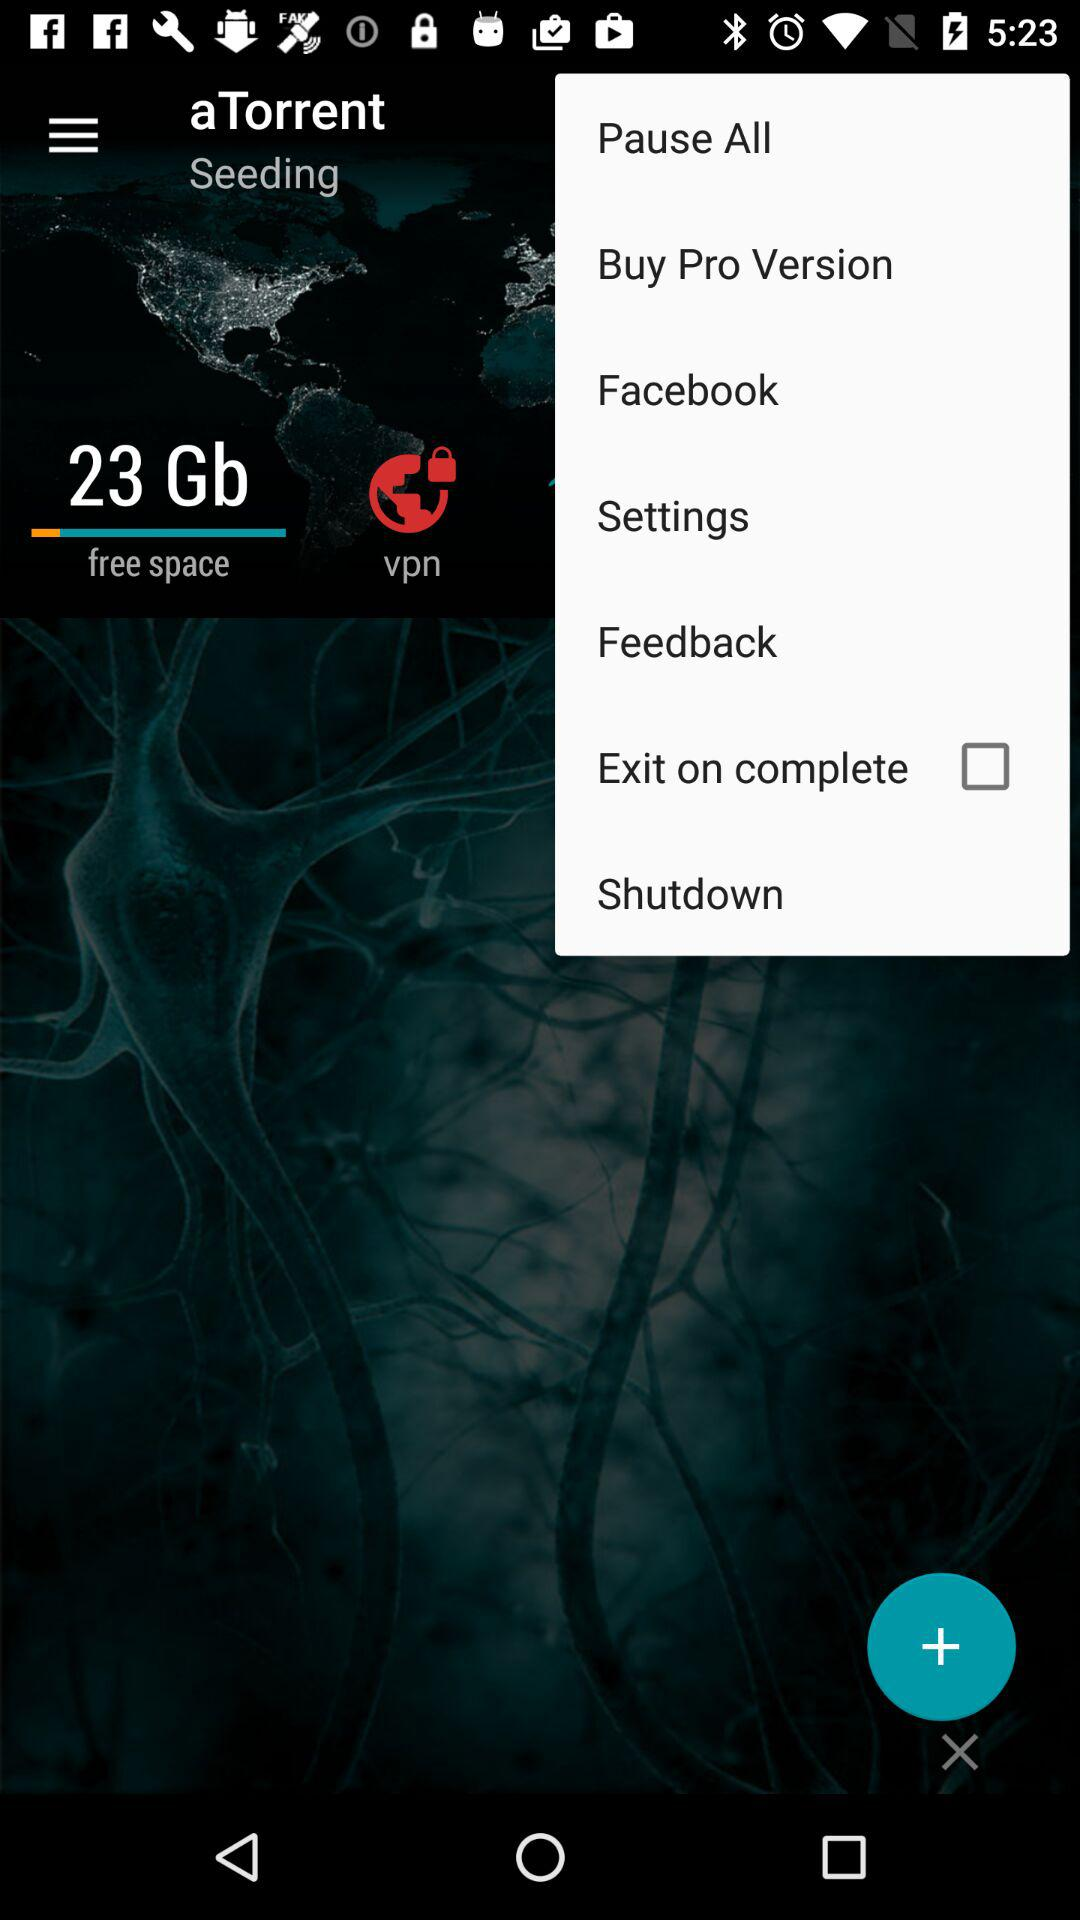What is the name of the application? The name of the application is "aTorrent". 